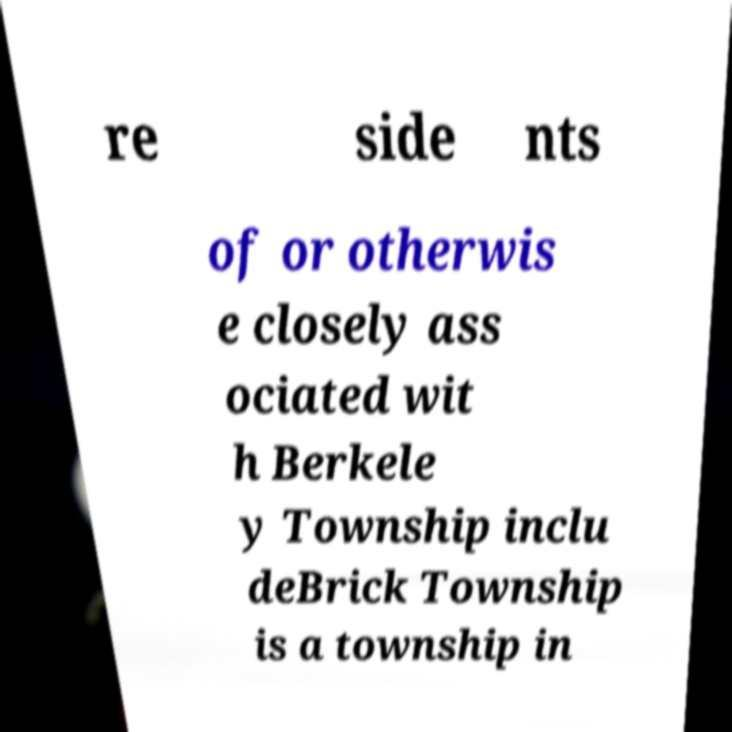Please read and relay the text visible in this image. What does it say? re side nts of or otherwis e closely ass ociated wit h Berkele y Township inclu deBrick Township is a township in 